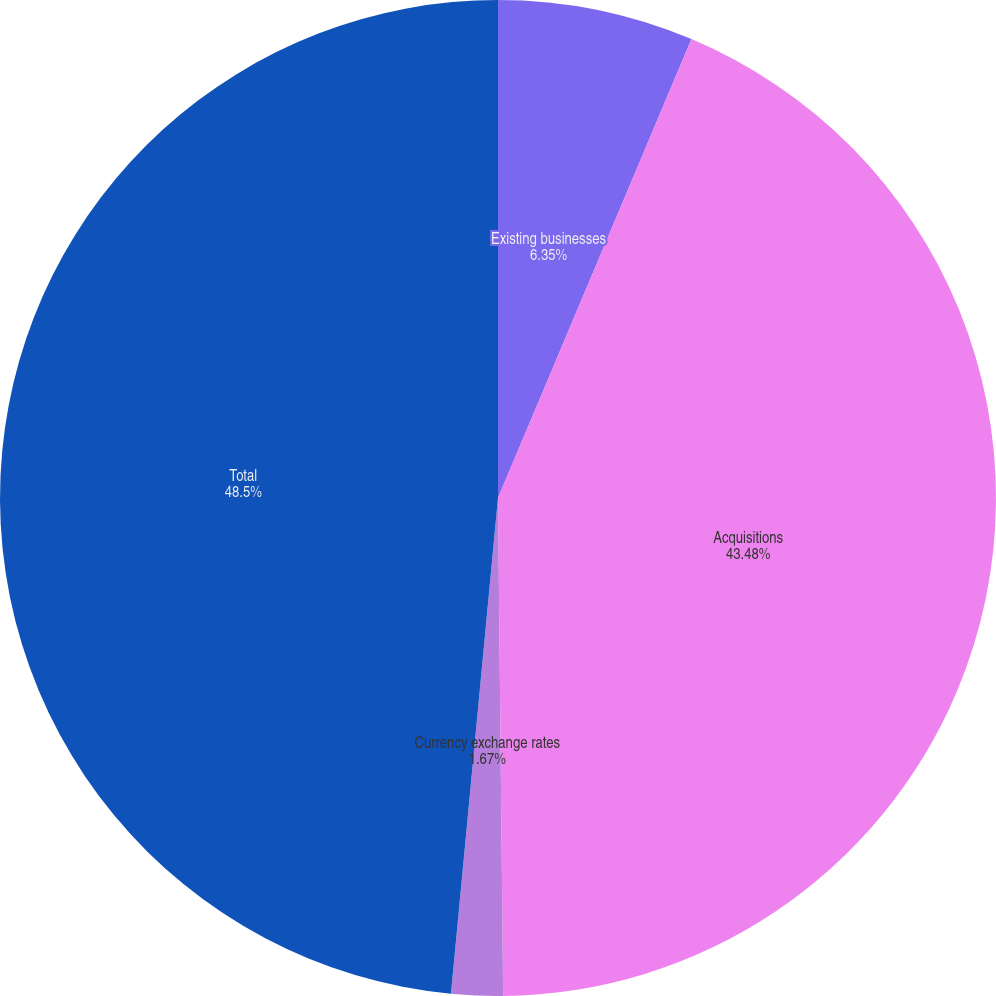Convert chart to OTSL. <chart><loc_0><loc_0><loc_500><loc_500><pie_chart><fcel>Existing businesses<fcel>Acquisitions<fcel>Currency exchange rates<fcel>Total<nl><fcel>6.35%<fcel>43.48%<fcel>1.67%<fcel>48.49%<nl></chart> 